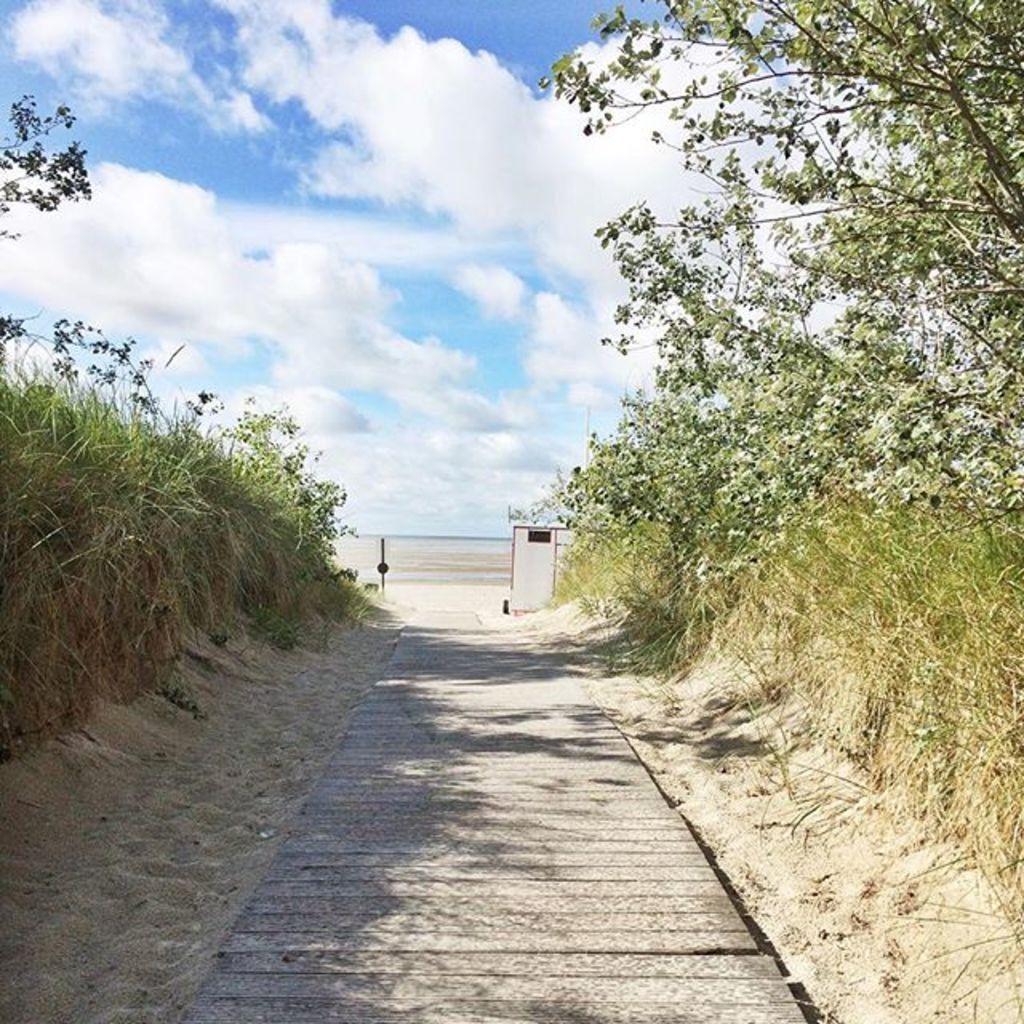What type of surface can be seen in the image? There is a path in the image. What type of terrain is visible in the image? There is sand and grass in the image. What type of vegetation is present in the image? There are trees in the image. What is visible in the background of the image? The sky is visible in the background of the image. What can be seen in the sky? Clouds are present in the sky. How many houses are visible in the image? There are no houses present in the image. What type of adjustment can be seen on the trees in the image? There is no adjustment visible on the trees in the image; they appear to be natural. 